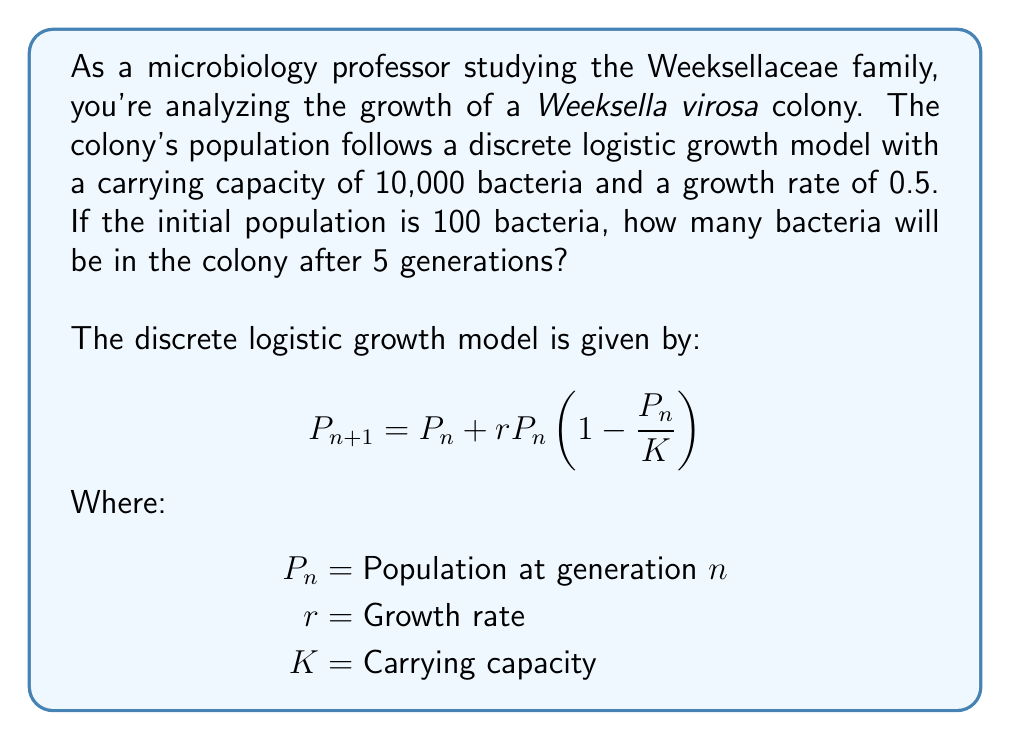Give your solution to this math problem. Let's solve this step-by-step:

1) We're given:
   Initial population $P_0 = 100$
   Growth rate $r = 0.5$
   Carrying capacity $K = 10,000$

2) We need to calculate $P_5$ using the discrete logistic growth model.

3) Let's calculate each generation:

   For $n = 0$:
   $P_1 = 100 + 0.5 \cdot 100 \cdot (1 - \frac{100}{10000}) = 100 + 49.5 = 149.5$

   For $n = 1$:
   $P_2 = 149.5 + 0.5 \cdot 149.5 \cdot (1 - \frac{149.5}{10000}) = 149.5 + 73.88 = 223.38$

   For $n = 2$:
   $P_3 = 223.38 + 0.5 \cdot 223.38 \cdot (1 - \frac{223.38}{10000}) = 223.38 + 109.53 = 332.91$

   For $n = 3$:
   $P_4 = 332.91 + 0.5 \cdot 332.91 \cdot (1 - \frac{332.91}{10000}) = 332.91 + 161.62 = 494.53$

   For $n = 4$:
   $P_5 = 494.53 + 0.5 \cdot 494.53 \cdot (1 - \frac{494.53}{10000}) = 494.53 + 237.29 = 731.82$

4) Therefore, after 5 generations, the population will be approximately 732 bacteria.
Answer: 732 bacteria 